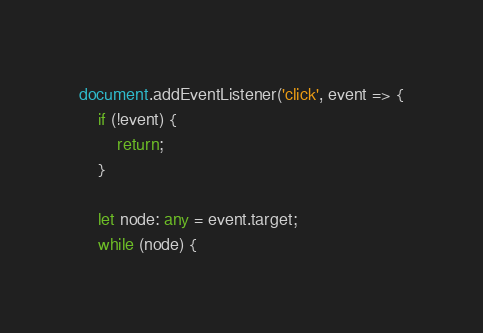Convert code to text. <code><loc_0><loc_0><loc_500><loc_500><_TypeScript_>document.addEventListener('click', event => {
	if (!event) {
		return;
	}

	let node: any = event.target;
	while (node) {</code> 